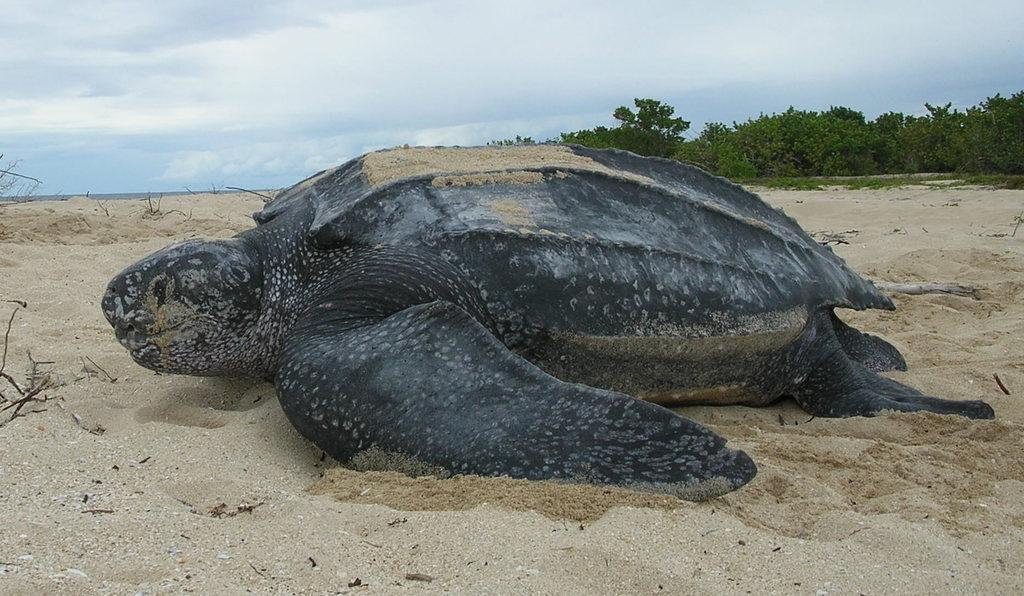What type of animal is in the image? There is a tortoise in the image. What is the surface that the tortoise is on? The tortoise is on a sand surface. What can be seen in the background of the image? There are trees and the sky visible in the image. What type of dinner is being served in the image? There is no dinner present in the image; it features a tortoise on a sand surface with trees and the sky visible in the background. 